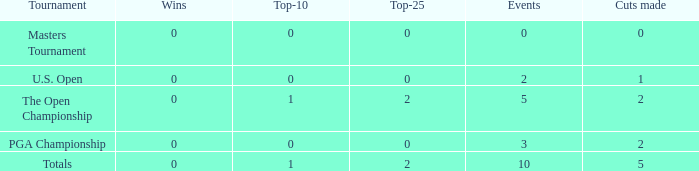What is the combined sum of top-25s for instances with 0 successes? 0.0. 